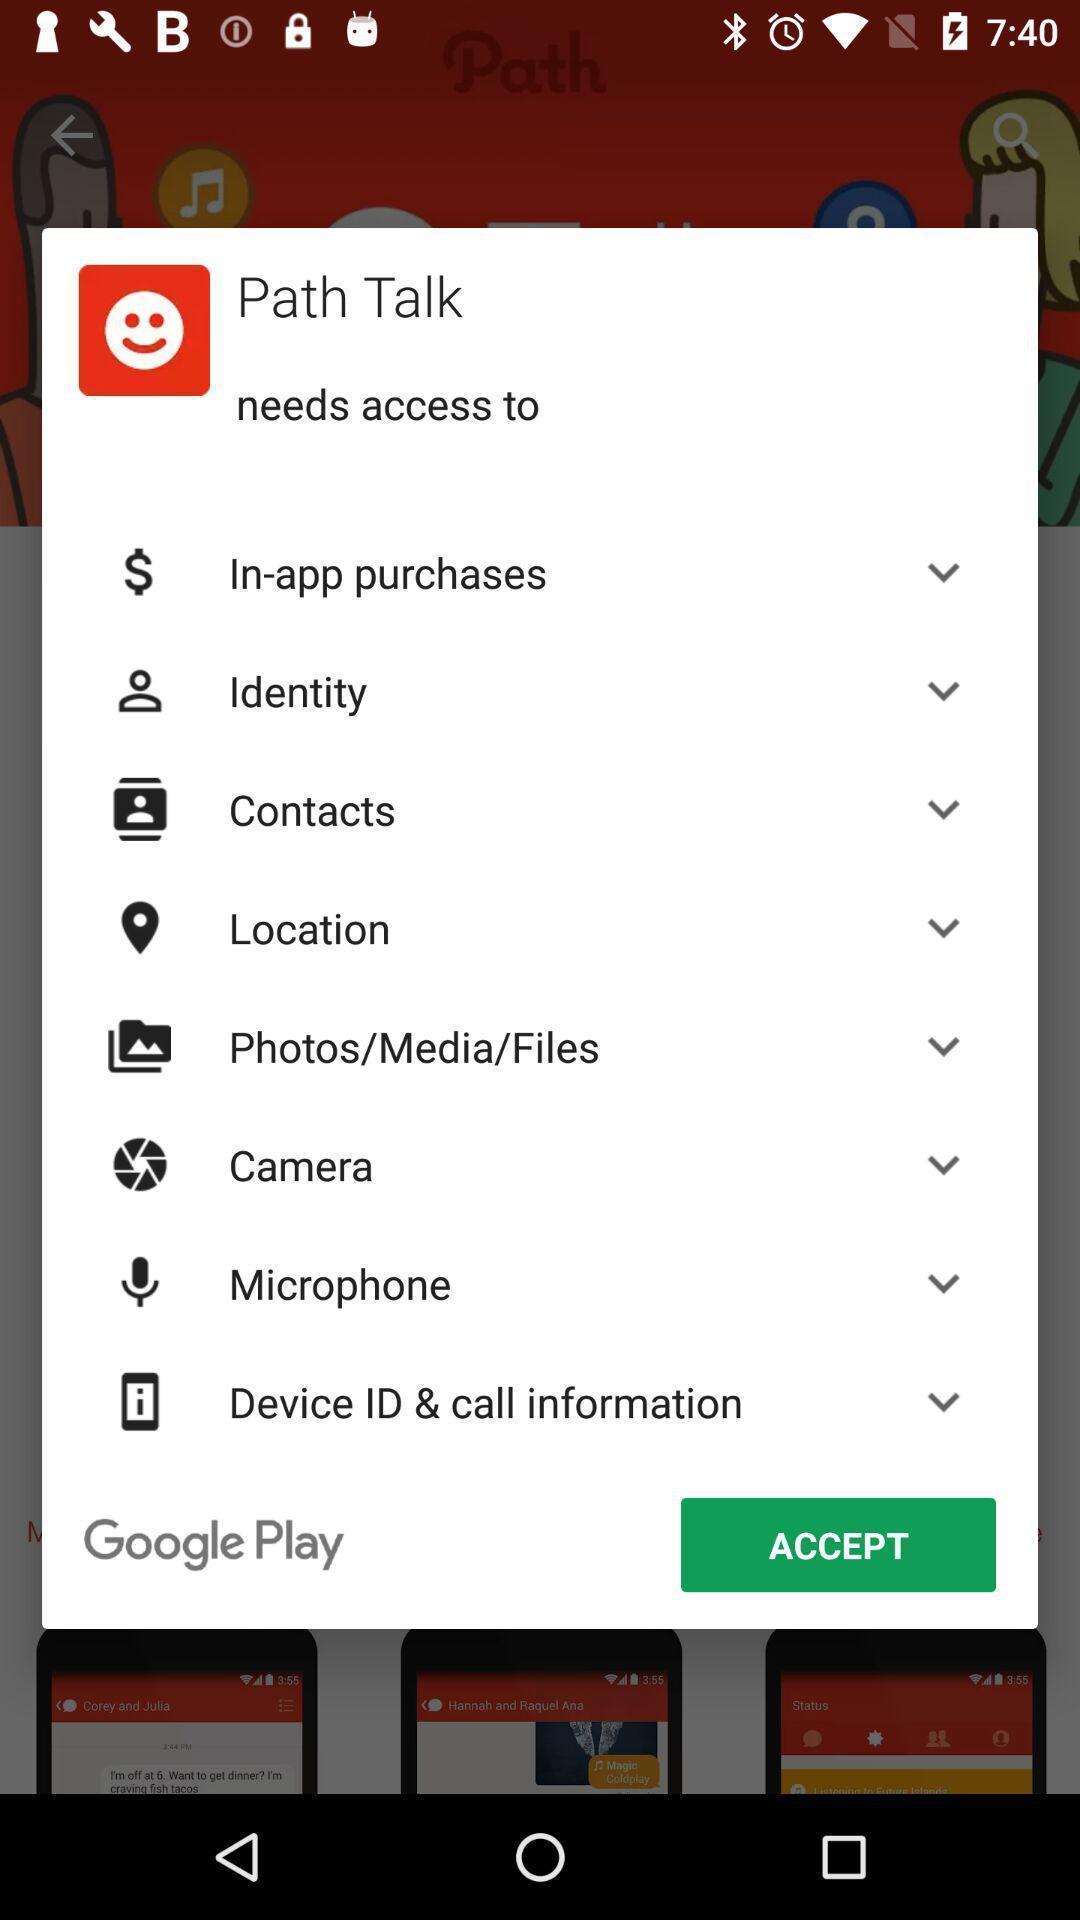Give me a narrative description of this picture. Pop-up to allow the access permissions for an app. 